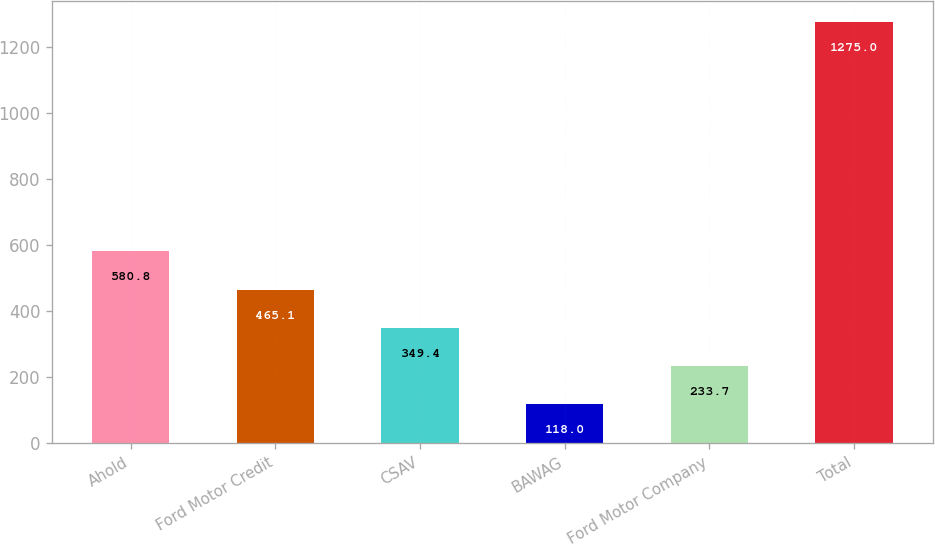Convert chart to OTSL. <chart><loc_0><loc_0><loc_500><loc_500><bar_chart><fcel>Ahold<fcel>Ford Motor Credit<fcel>CSAV<fcel>BAWAG<fcel>Ford Motor Company<fcel>Total<nl><fcel>580.8<fcel>465.1<fcel>349.4<fcel>118<fcel>233.7<fcel>1275<nl></chart> 